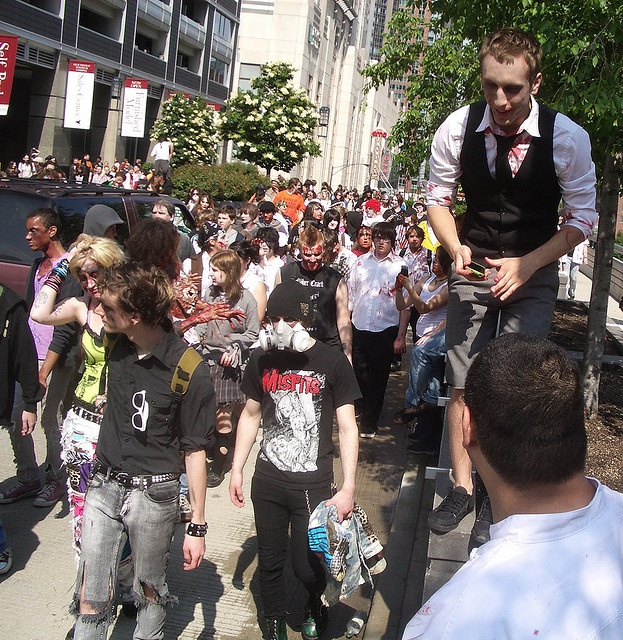Describe the objects in this image and their specific colors. I can see people in black, gray, white, and maroon tones, people in black, gray, darkgray, and maroon tones, people in black, lavender, and brown tones, people in black, gray, and darkgray tones, and people in black, lightgray, and gray tones in this image. 